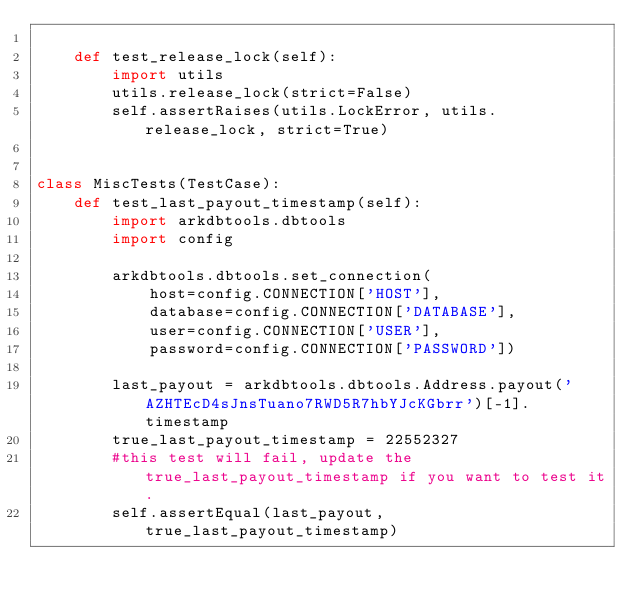Convert code to text. <code><loc_0><loc_0><loc_500><loc_500><_Python_>
    def test_release_lock(self):
        import utils
        utils.release_lock(strict=False)
        self.assertRaises(utils.LockError, utils.release_lock, strict=True)


class MiscTests(TestCase):
    def test_last_payout_timestamp(self):
        import arkdbtools.dbtools
        import config

        arkdbtools.dbtools.set_connection(
            host=config.CONNECTION['HOST'],
            database=config.CONNECTION['DATABASE'],
            user=config.CONNECTION['USER'],
            password=config.CONNECTION['PASSWORD'])

        last_payout = arkdbtools.dbtools.Address.payout('AZHTEcD4sJnsTuano7RWD5R7hbYJcKGbrr')[-1].timestamp
        true_last_payout_timestamp = 22552327
        #this test will fail, update the true_last_payout_timestamp if you want to test it.
        self.assertEqual(last_payout, true_last_payout_timestamp)</code> 